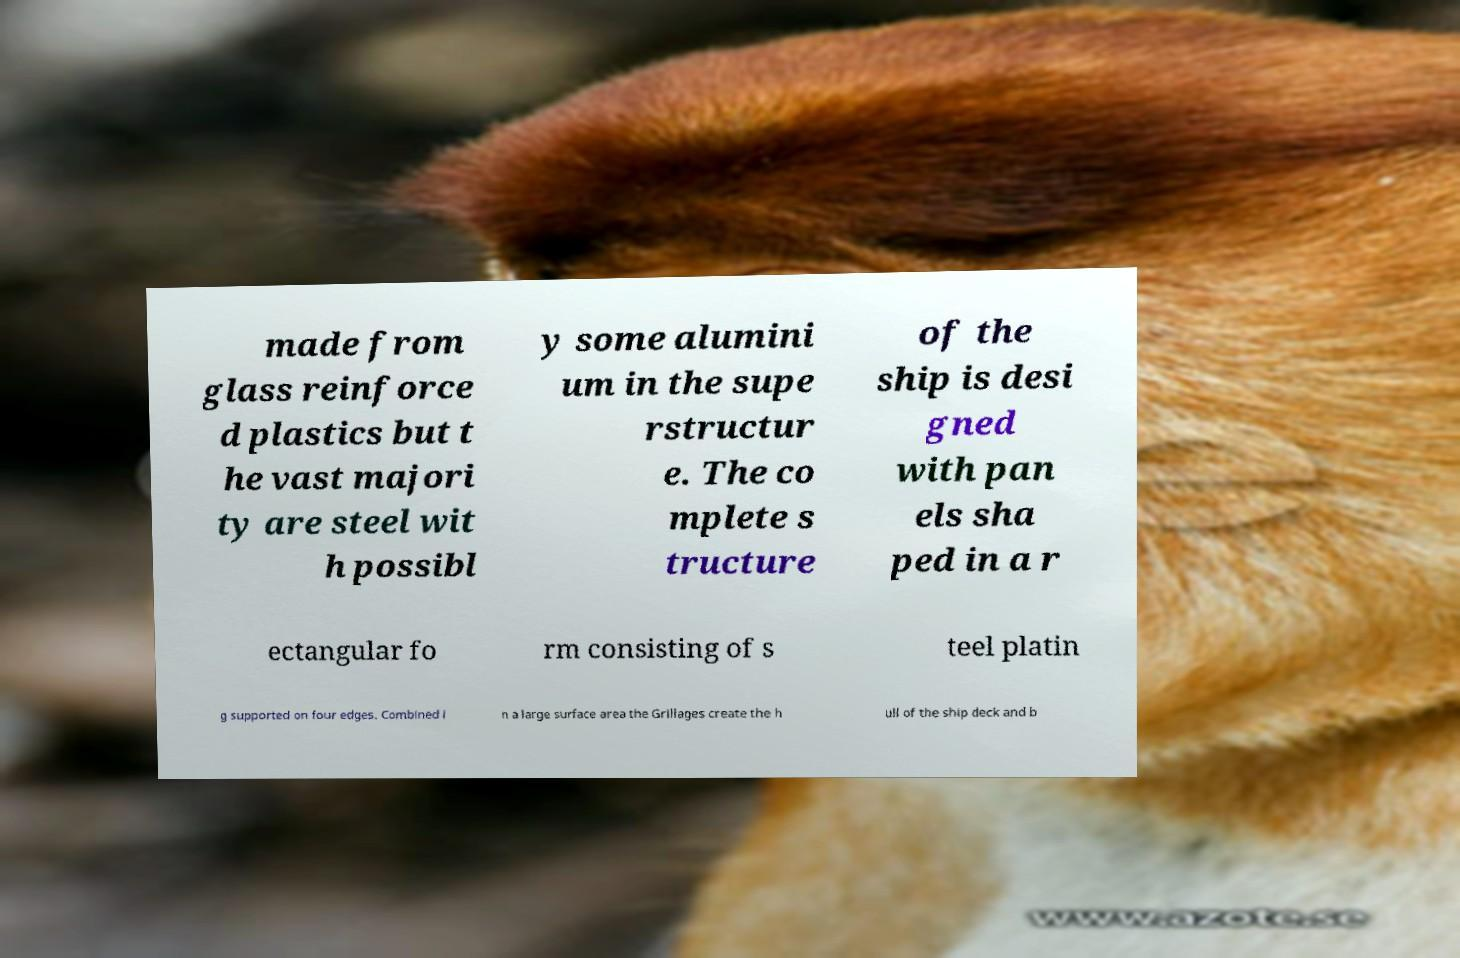Could you assist in decoding the text presented in this image and type it out clearly? made from glass reinforce d plastics but t he vast majori ty are steel wit h possibl y some alumini um in the supe rstructur e. The co mplete s tructure of the ship is desi gned with pan els sha ped in a r ectangular fo rm consisting of s teel platin g supported on four edges. Combined i n a large surface area the Grillages create the h ull of the ship deck and b 